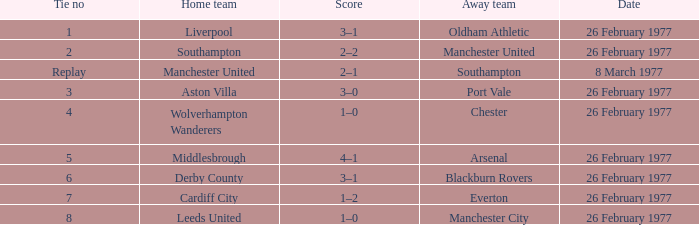Who was the domestic team that played against manchester united? Southampton. 